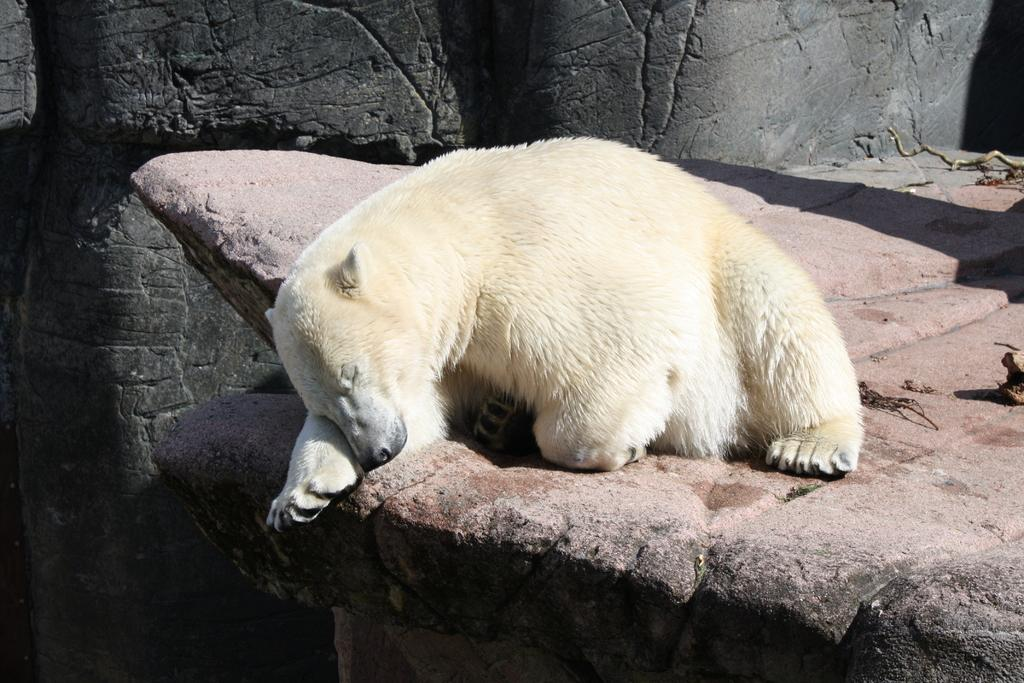What type of animal is in the image? There is a polar bear in the image. What is the polar bear standing on in the image? The polar bear is standing on a rock in the image. What else can be seen on the rock in the image? There are objects on the rock in the image. What can be seen in the background of the image? There are rocks visible in the background of the image. Can you tell me what type of quilt the man is holding in the image? There is no man or quilt present in the image; it features a polar bear standing on a rock with objects on it. 